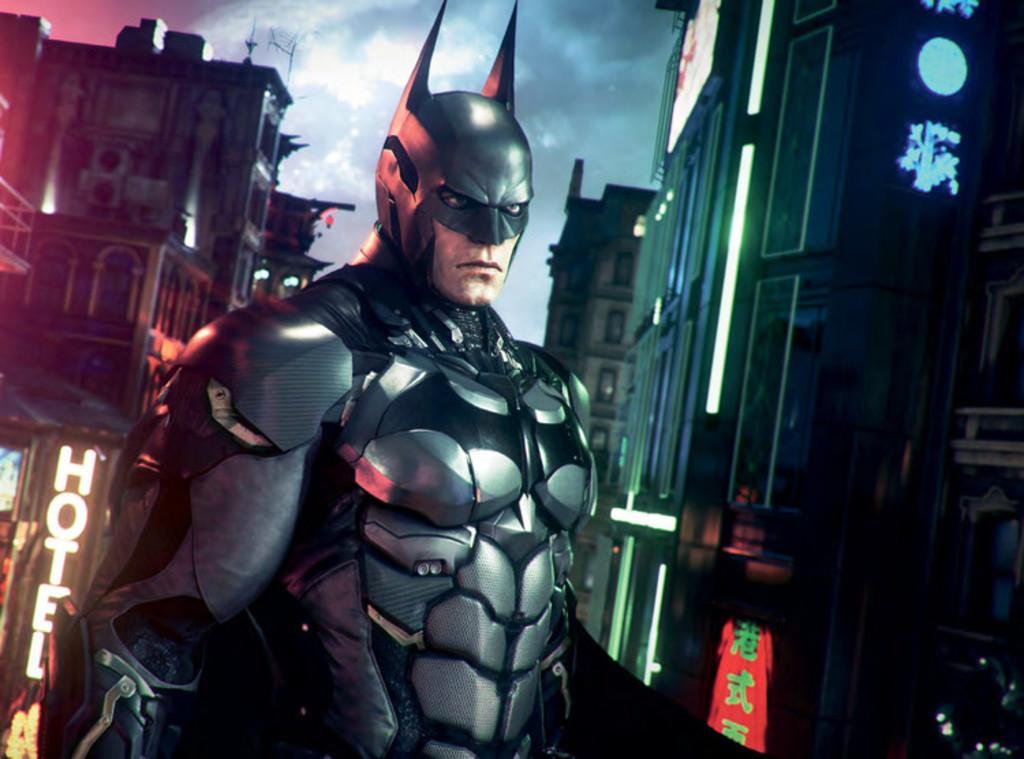Please provide a concise description of this image. This is an animated image. In this image, in the middle, we can see a man wearing a costume which is in black color. On the right side, we can see some buildings, hoardings, lights. On the left side, we can also see some text written on the building. At the top, we can see a sky which is cloudy. 